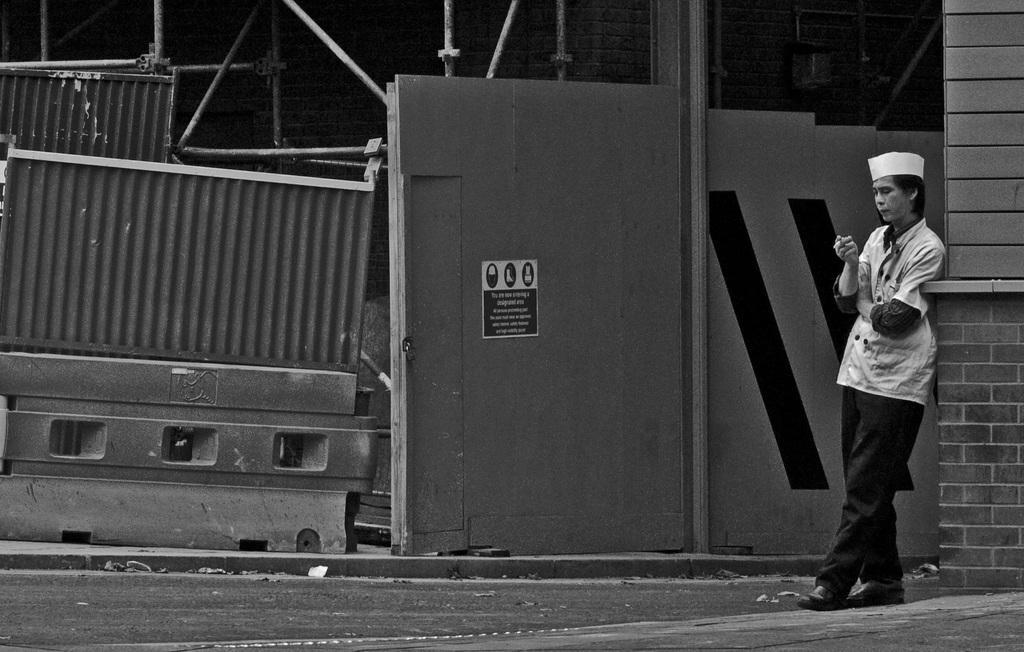How would you summarize this image in a sentence or two? In this image, on the right side, we can see a person standing at the wall, we can see a divider on the ground. 